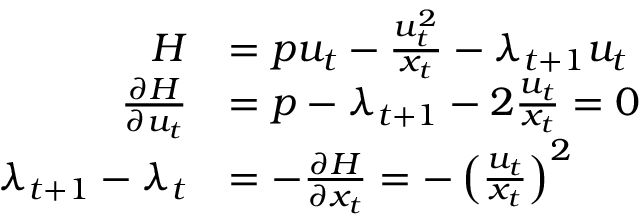Convert formula to latex. <formula><loc_0><loc_0><loc_500><loc_500>{ \begin{array} { r l } { H } & { = p u _ { t } - { \frac { u _ { t } ^ { 2 } } { x _ { t } } } - \lambda _ { t + 1 } u _ { t } } \\ { { \frac { \partial H } { \partial u _ { t } } } } & { = p - \lambda _ { t + 1 } - 2 { \frac { u _ { t } } { x _ { t } } } = 0 } \\ { \lambda _ { t + 1 } - \lambda _ { t } } & { = - { \frac { \partial H } { \partial x _ { t } } } = - \left ( { \frac { u _ { t } } { x _ { t } } } \right ) ^ { 2 } } \end{array} }</formula> 